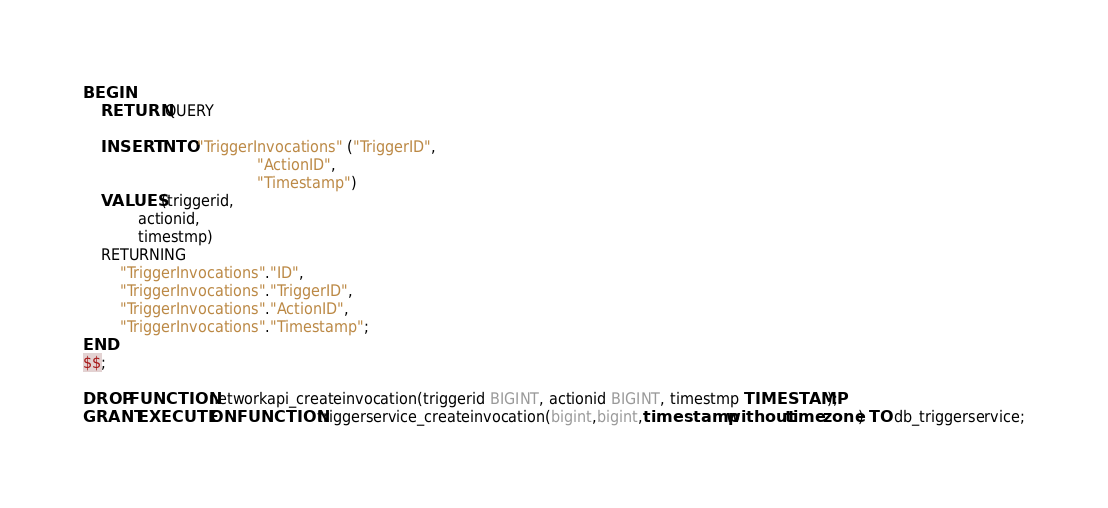Convert code to text. <code><loc_0><loc_0><loc_500><loc_500><_SQL_>BEGIN
	RETURN QUERY

    INSERT INTO "TriggerInvocations" ("TriggerID",
                                      "ActionID",
                                      "Timestamp")
    VALUES (triggerid,
            actionid,
            timestmp)
    RETURNING
        "TriggerInvocations"."ID",
        "TriggerInvocations"."TriggerID",
        "TriggerInvocations"."ActionID",
        "TriggerInvocations"."Timestamp";
END
$$;

DROP FUNCTION networkapi_createinvocation(triggerid BIGINT, actionid BIGINT, timestmp TIMESTAMP);
GRANT EXECUTE ON FUNCTION triggerservice_createinvocation(bigint,bigint,timestamp without time zone) TO db_triggerservice;
</code> 